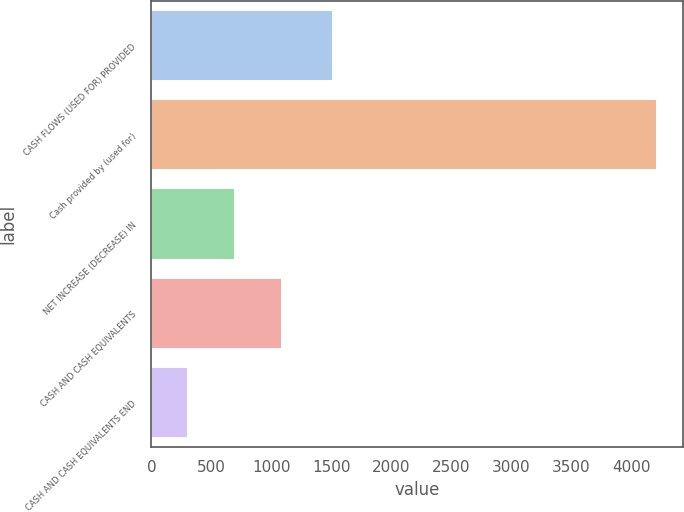Convert chart. <chart><loc_0><loc_0><loc_500><loc_500><bar_chart><fcel>CASH FLOWS (USED FOR) PROVIDED<fcel>Cash provided by (used for)<fcel>NET INCREASE (DECREASE) IN<fcel>CASH AND CASH EQUIVALENTS<fcel>CASH AND CASH EQUIVALENTS END<nl><fcel>1511<fcel>4218<fcel>698.1<fcel>1089.2<fcel>307<nl></chart> 